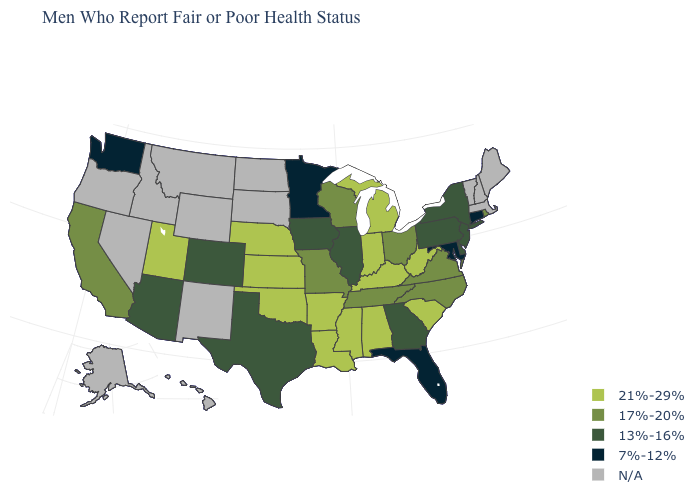Name the states that have a value in the range 13%-16%?
Write a very short answer. Arizona, Colorado, Delaware, Georgia, Illinois, Iowa, New Jersey, New York, Pennsylvania, Texas. Does the first symbol in the legend represent the smallest category?
Answer briefly. No. Name the states that have a value in the range N/A?
Keep it brief. Alaska, Hawaii, Idaho, Maine, Massachusetts, Montana, Nevada, New Hampshire, New Mexico, North Dakota, Oregon, South Dakota, Vermont, Wyoming. Name the states that have a value in the range 17%-20%?
Answer briefly. California, Missouri, North Carolina, Ohio, Rhode Island, Tennessee, Virginia, Wisconsin. Does Washington have the lowest value in the West?
Answer briefly. Yes. Which states hav the highest value in the MidWest?
Answer briefly. Indiana, Kansas, Michigan, Nebraska. Does Utah have the highest value in the USA?
Answer briefly. Yes. Among the states that border New York , which have the lowest value?
Be succinct. Connecticut. What is the value of Alabama?
Short answer required. 21%-29%. Does Maryland have the lowest value in the USA?
Keep it brief. Yes. Does Pennsylvania have the lowest value in the Northeast?
Keep it brief. No. How many symbols are there in the legend?
Quick response, please. 5. What is the value of South Dakota?
Answer briefly. N/A. Does Georgia have the lowest value in the USA?
Be succinct. No. 